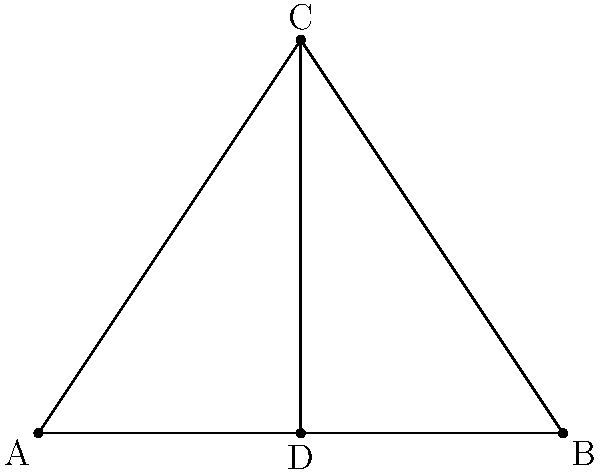A speculum diagram is represented by an isosceles triangle ABC with a line of symmetry CD. If angle $\theta$ at the apex C is 60°, what is the measure of angle $\alpha$ at the base? Let's approach this step-by-step:

1) In an isosceles triangle, the base angles are equal. Let's call each base angle $\beta$.

2) The sum of angles in a triangle is always 180°. So:
   $$\theta + \beta + \beta = 180°$$
   $$60° + 2\beta = 180°$$

3) Solving for $\beta$:
   $$2\beta = 120°$$
   $$\beta = 60°$$

4) The line CD is a line of symmetry, which means it bisects the angle at C and the side AB.

5) Angle $\alpha$ is half of angle $\beta$, because CD bisects the base angle.

6) Therefore:
   $$\alpha = \frac{\beta}{2} = \frac{60°}{2} = 30°$$

Thus, the measure of angle $\alpha$ is 30°.
Answer: 30° 